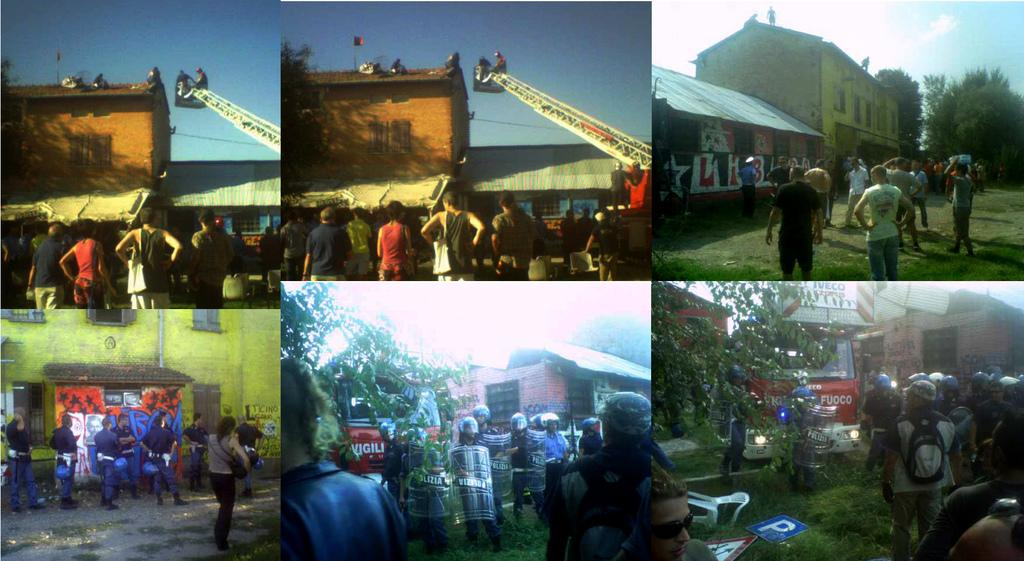What type of artwork is the image? The image is a collage. What structures can be seen in the image? There are houses in the image. What type of vegetation is present in the image? There are trees in the image. Who or what else can be seen in the image? There are people and cranes in the image. What part of the natural environment is visible in the image? The sky and grass are visible in the image. What degree does the person in the image hold? There is no indication of a person's degree in the image. What topic are the people in the image discussing? There is no conversation or discussion depicted in the image. 